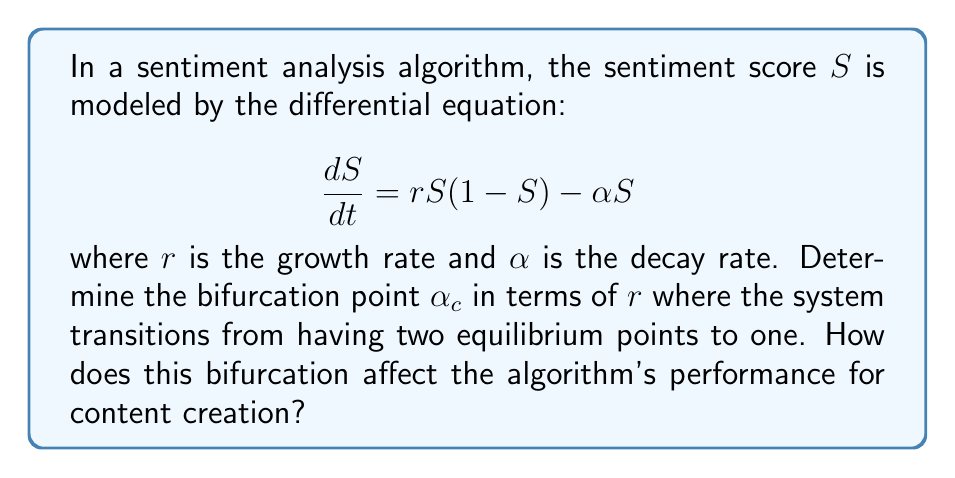Can you answer this question? 1) First, we find the equilibrium points by setting $\frac{dS}{dt} = 0$:

   $$rS(1-S) - \alpha S = 0$$

2) Factor out S:

   $$S(r(1-S) - \alpha) = 0$$

3) Solve for S:
   
   $S = 0$ or $r(1-S) - \alpha = 0$

4) From the second equation:
   
   $$r - rS - \alpha = 0$$
   $$rS = r - \alpha$$
   $$S = 1 - \frac{\alpha}{r}$$

5) The system has two equilibrium points when $0 < 1 - \frac{\alpha}{r} < 1$, or when $0 < \alpha < r$.

6) The bifurcation occurs when these two equilibrium points merge, i.e., when $\alpha = r$.

7) Therefore, the bifurcation point $\alpha_c = r$.

8) For the algorithm's performance:
   - When $\alpha < r$, there are two equilibrium points: $S = 0$ and $S = 1 - \frac{\alpha}{r}$. This allows for a more nuanced sentiment analysis, as the algorithm can distinguish between two stable states.
   - When $\alpha = r$ (at the bifurcation point), there's only one equilibrium point at $S = 0$. This results in a loss of sensitivity in the sentiment analysis.
   - When $\alpha > r$, only the $S = 0$ equilibrium remains stable, potentially leading to all content being classified as neutral, regardless of actual sentiment.
Answer: $\alpha_c = r$ 